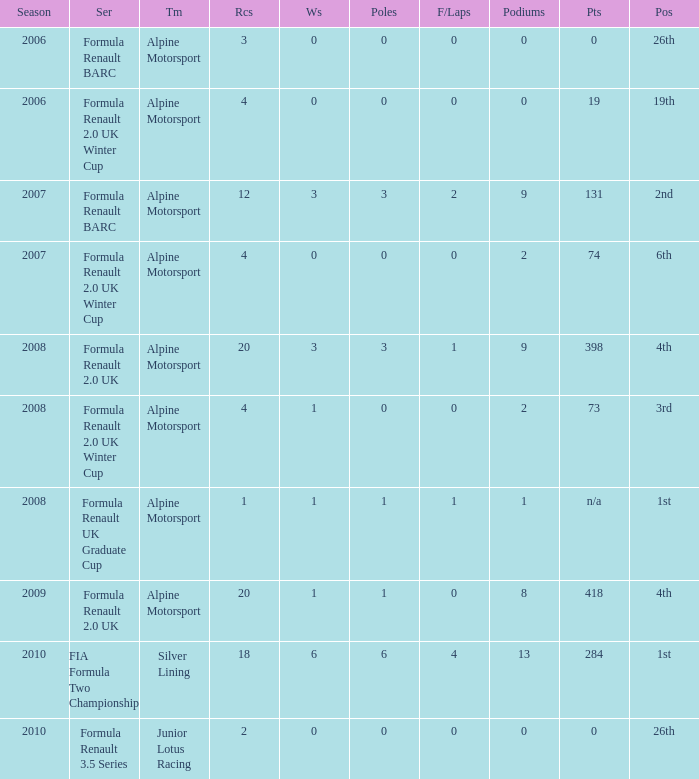What races achieved 0 f/laps and 1 pole position? 20.0. 